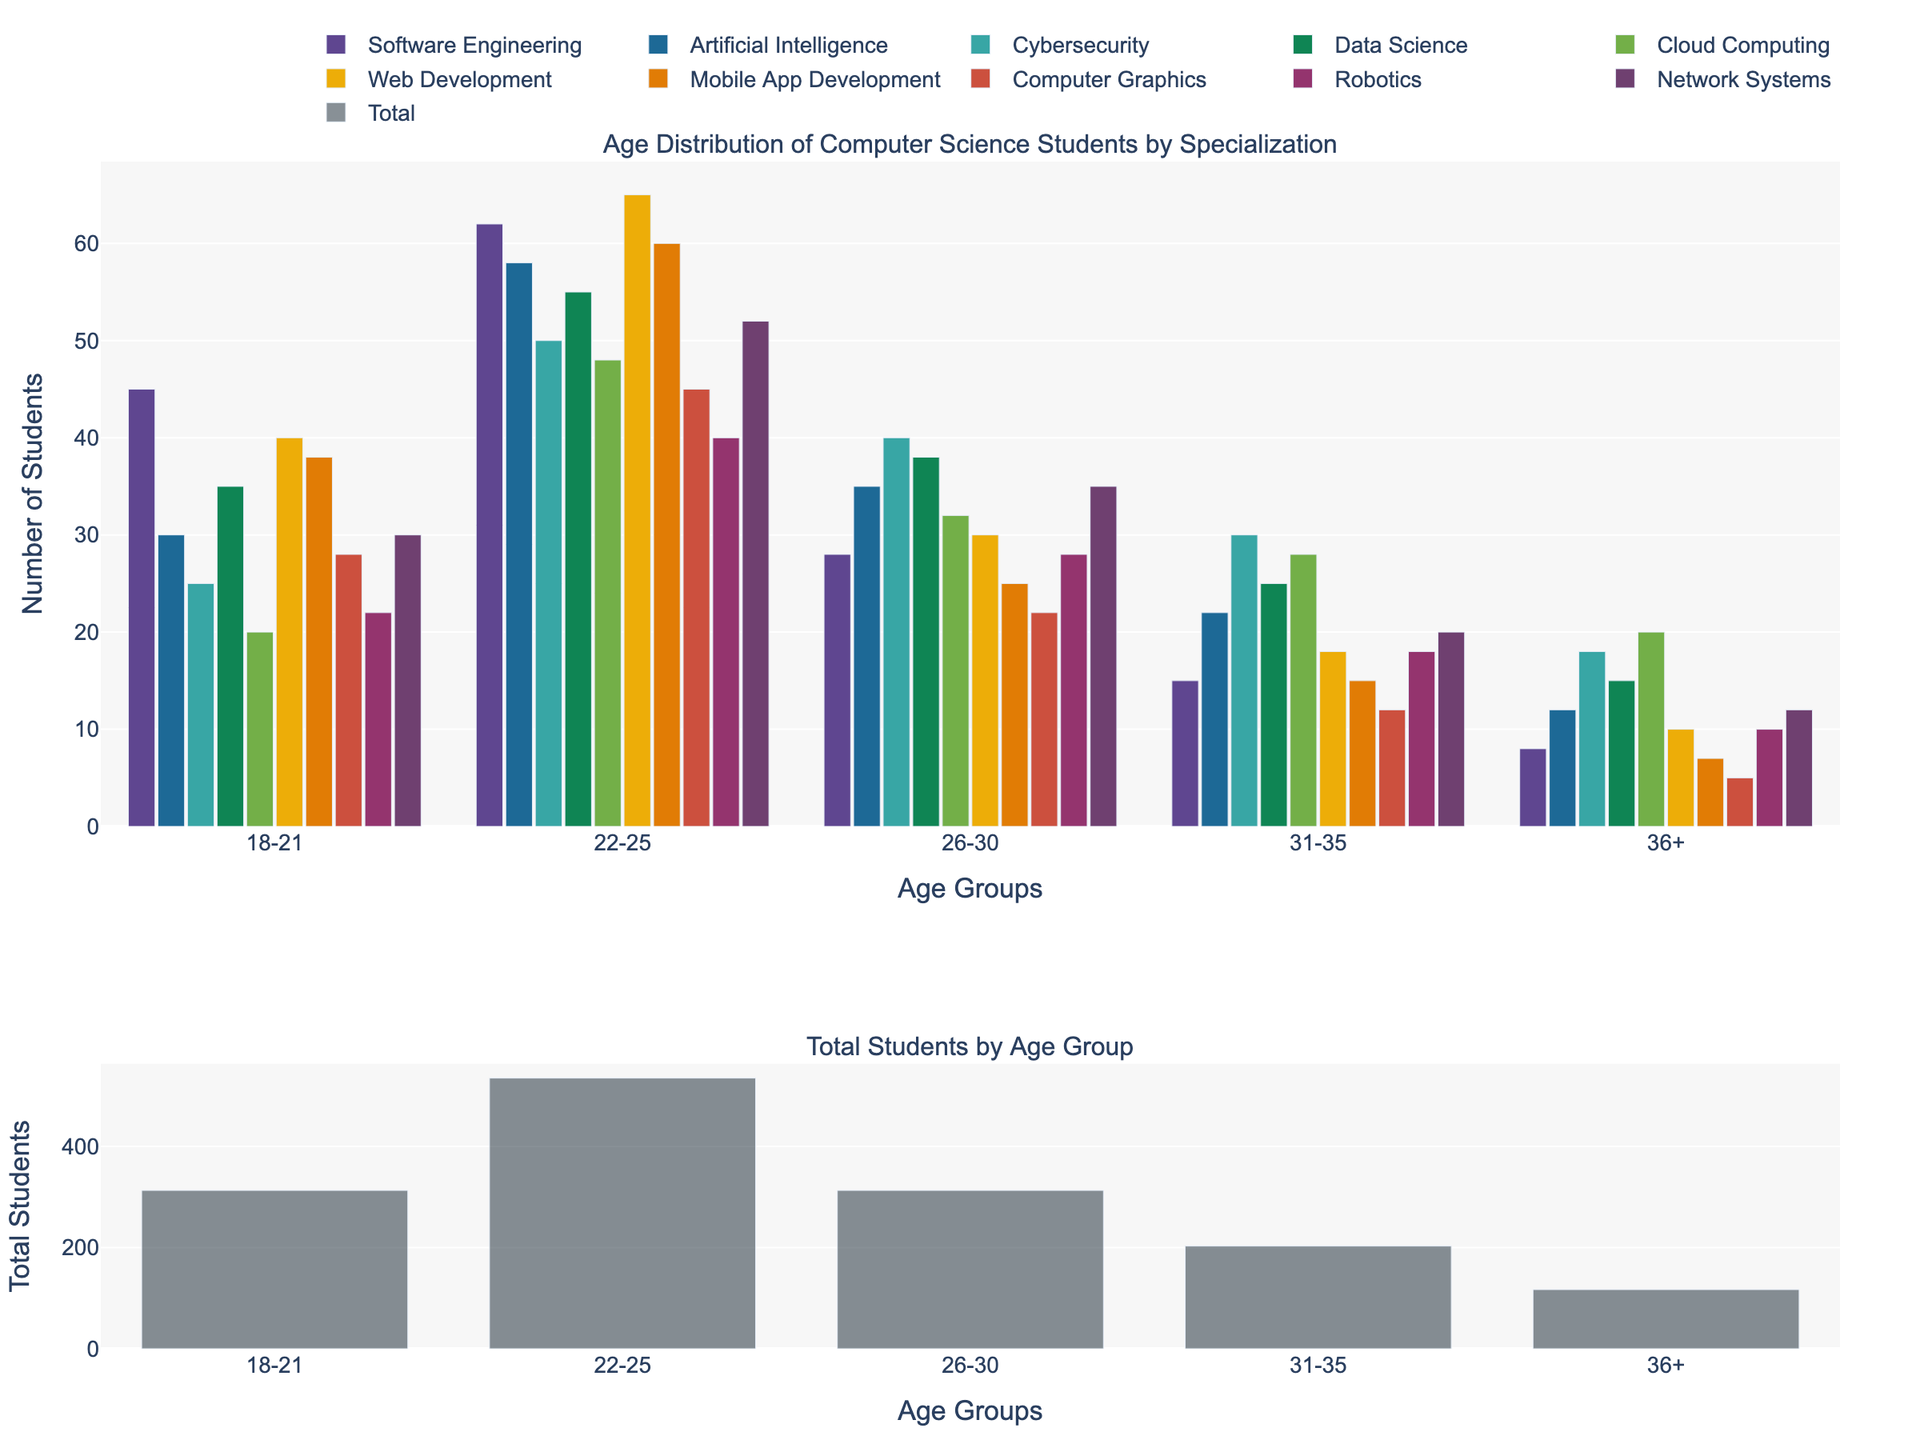What are the titles of the two subplots? The titles are located at the top of each subplot. The top subplot has the title "Age Distribution of Computer Science Students by Specialization" and the bottom subplot is titled "Total Students by Age Group".
Answer: "Age Distribution of Computer Science Students by Specialization" and "Total Students by Age Group" Which specialization has the highest number of students in the 22-25 age group? To answer this, look at the bars for the 22-25 age group in the top subplot. The specialization with the tallest bar in this group is Web Development with 65 students.
Answer: Web Development How many total students are there in the 31-35 age group across all specializations? First, find the value of the bar representing the 31-35 age group in the bottom subplot. The height of this bar indicates 183 students in the 31-35 age group.
Answer: 183 What is the difference in the number of students between the youngest (18-21) and the oldest (36+) age groups for Data Science? Locate the bars for Data Science in the 18-21 and 36+ age groups in the top subplot. There are 35 students in the 18-21 age group and 15 students in the 36+ age group. The difference is 35 - 15 = 20.
Answer: 20 Which specialization has the least number of students in the 26-30 age group? Look at the heights of the bars corresponding to the 26-30 age group in the top subplot. Computer Graphics has the shortest bar with 22 students in the 26-30 age group.
Answer: Computer Graphics What is the total number of students in the 18-21 age group across all specializations? Refer to the bottom subplot and find the value of the bar representing the 18-21 age group. The total number of students in this group is indicated as 313.
Answer: 313 How many students in total are pursuing Cybersecurity across all age groups? Sum the heights of the bars representing each age group for Cybersecurity in the top subplot. The values are 25 + 50 + 40 + 30 + 18 = 163.
Answer: 163 Which specialization shows a higher number of students in the 36+ age group: Cloud Computing or Robotics? Compare the heights of the bars for the 36+ age group between Cloud Computing and Robotics in the top subplot. Cloud Computing has 20 students and Robotics has 10 students in this age group.
Answer: Cloud Computing 